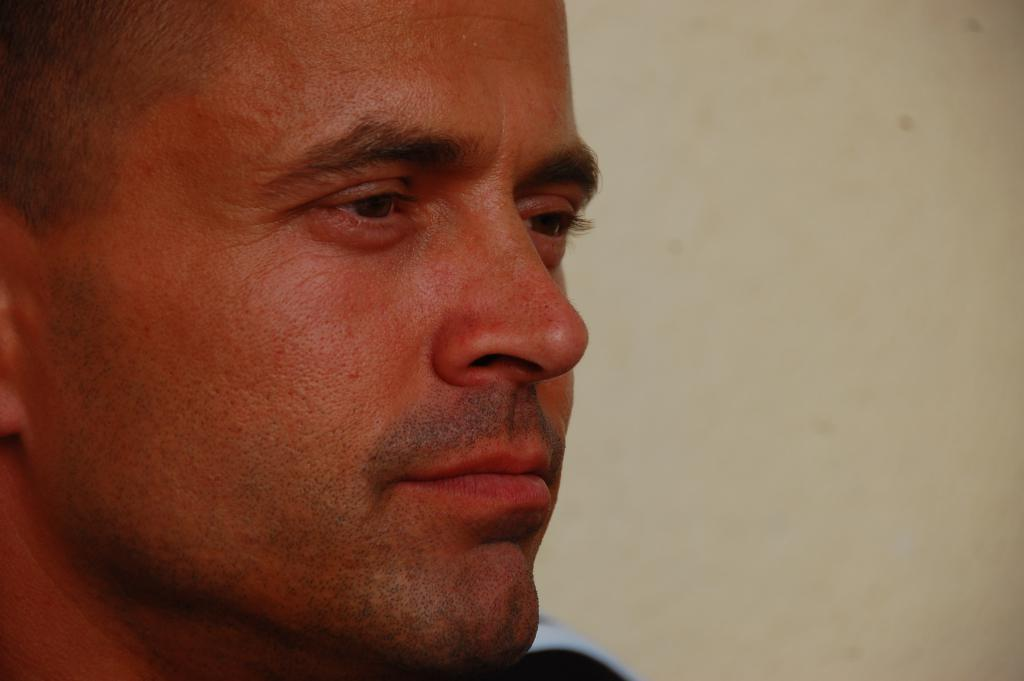What is the main subject of the image? The main subject of the image is a man's face. What can be seen behind the man in the image? There is a wall behind the man in the image. Is the man wearing a crown in the image? There is no crown visible in the image. How many times does the man twist his face in the image? The image does not show the man twisting his face, so it cannot be determined how many times he does so. 